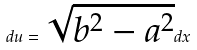<formula> <loc_0><loc_0><loc_500><loc_500>d u = \sqrt { b ^ { 2 } - a ^ { 2 } } d x</formula> 